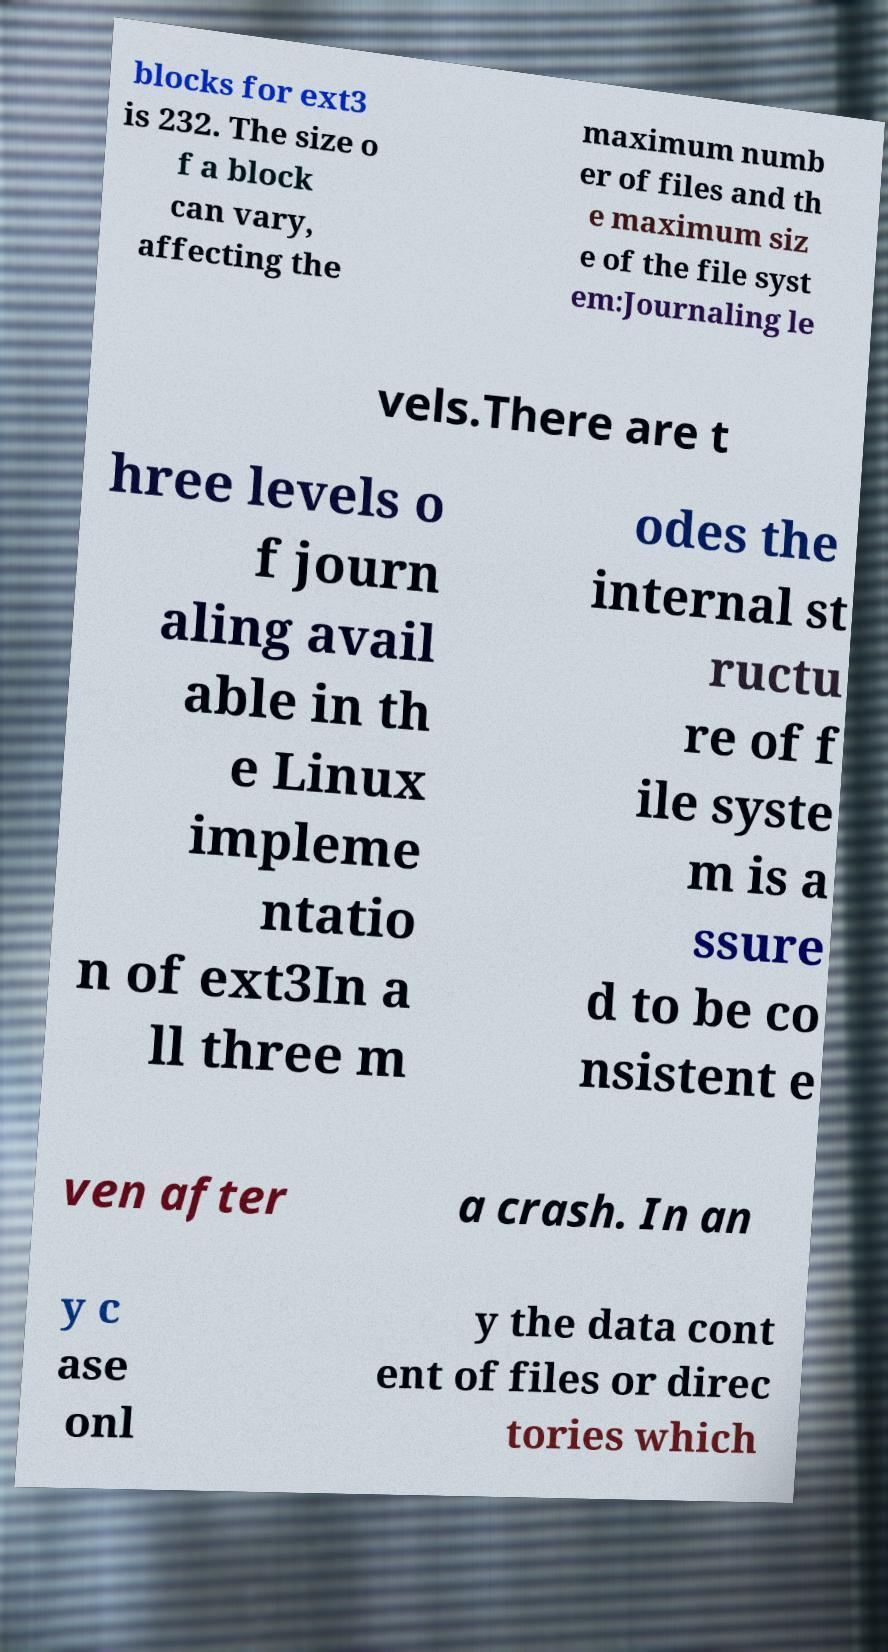Could you extract and type out the text from this image? blocks for ext3 is 232. The size o f a block can vary, affecting the maximum numb er of files and th e maximum siz e of the file syst em:Journaling le vels.There are t hree levels o f journ aling avail able in th e Linux impleme ntatio n of ext3In a ll three m odes the internal st ructu re of f ile syste m is a ssure d to be co nsistent e ven after a crash. In an y c ase onl y the data cont ent of files or direc tories which 